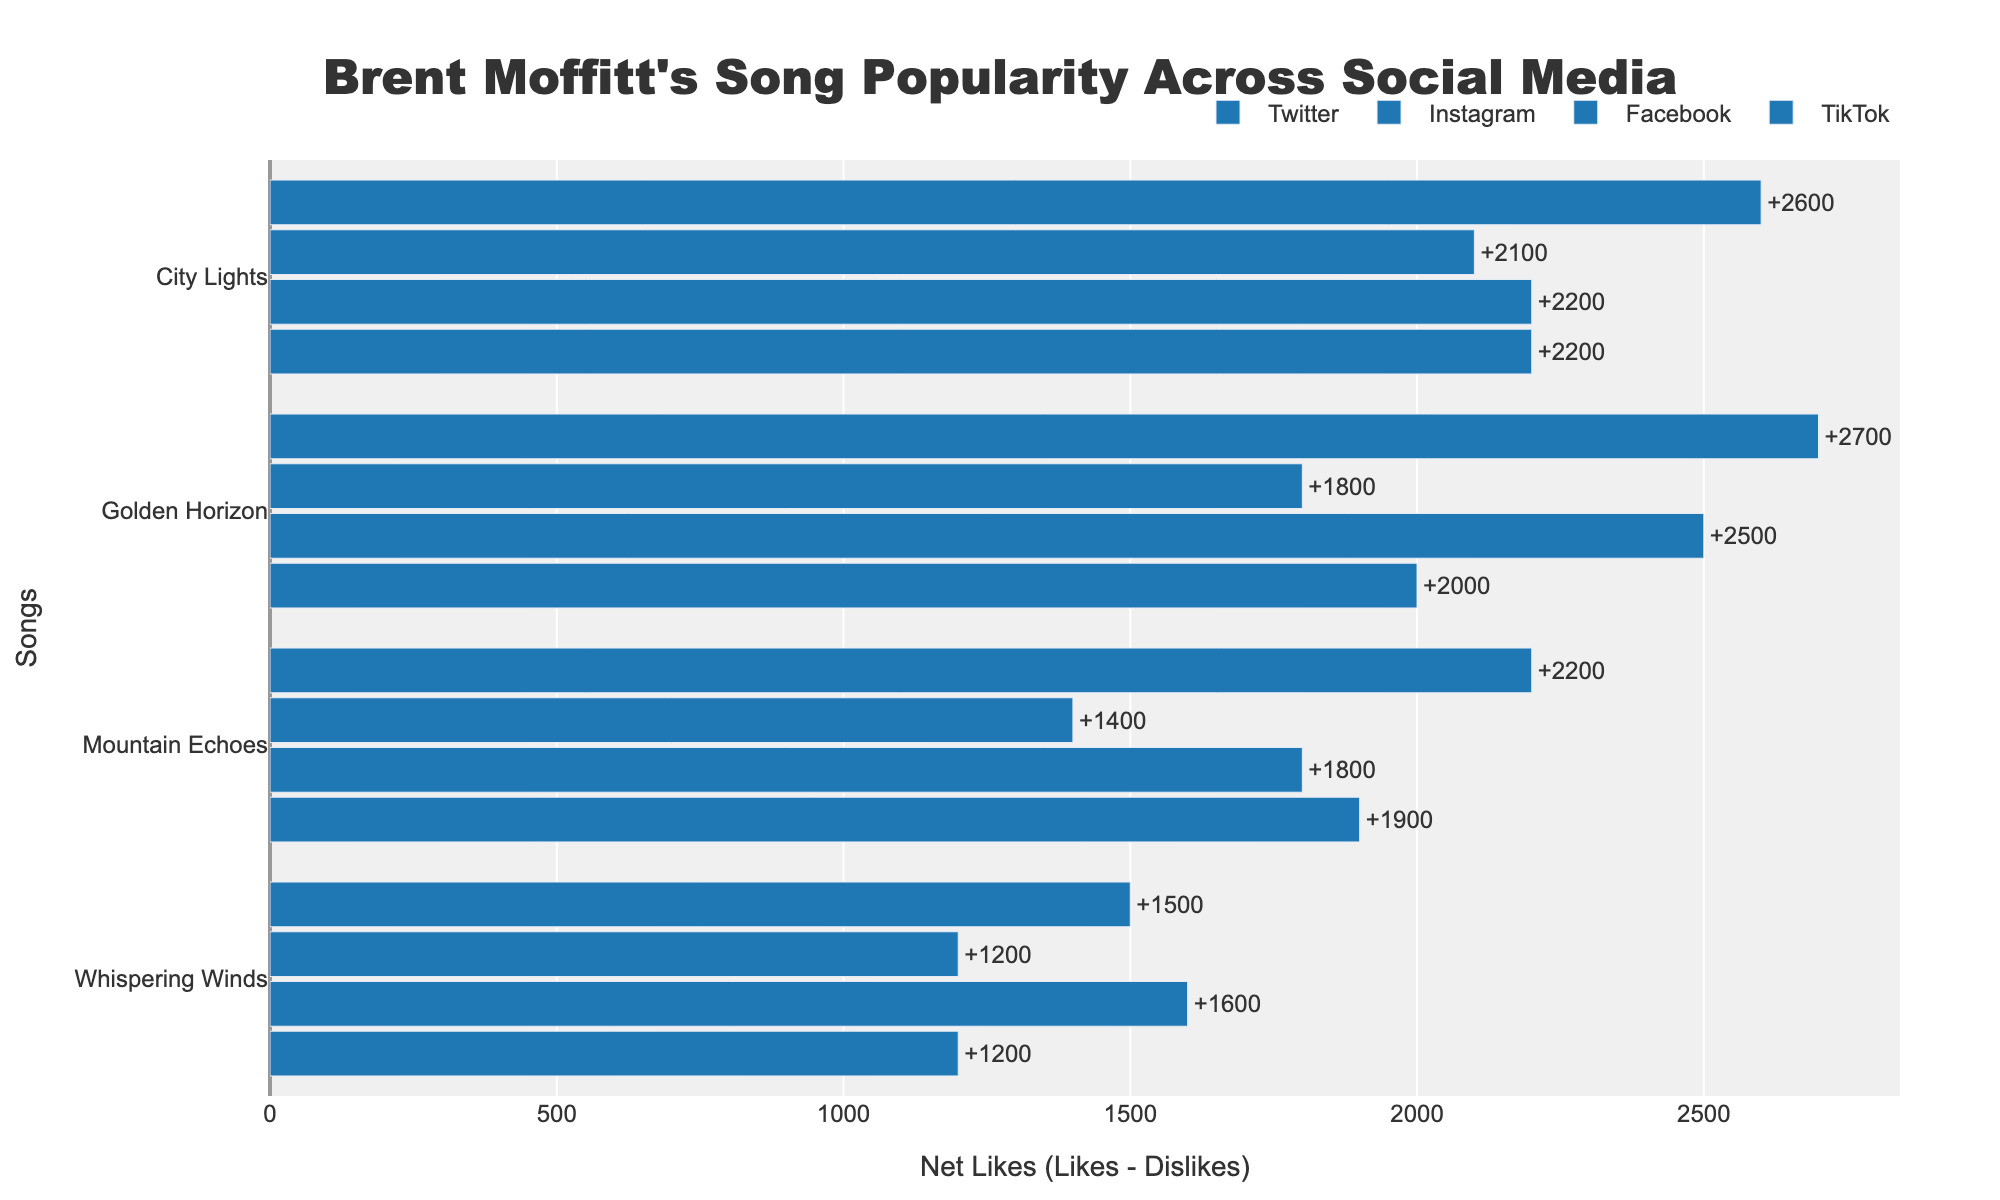How many net likes does "Golden Horizon" have on Twitter and Instagram combined? On Twitter, "Golden Horizon" has 2000 net likes (2500 Likes - 500 Dislikes). On Instagram, it has 2500 net likes (3200 Likes - 700 Dislikes). Summing them up, 2000 + 2500, the result is 4500 net likes.
Answer: 4500 Which song received the most net likes on TikTok? To determine this, we compare the net likes for each song on TikTok. "Golden Horizon" has 2700 net likes (3300 Likes - 600 Dislikes), "Whispering Winds" has 1500 net likes (2000 Likes - 500 Dislikes), "Mountain Echoes" has 2200 net likes (2700 Likes - 500 Dislikes), and "City Lights" has 2600 net likes (3500 Likes - 900 Dislikes). "Golden Horizon" has the most with 2700 net likes.
Answer: Golden Horizon How do the net likes for "City Lights" compare across all platforms? We need to compare the net likes for "City Lights" on each platform. Twitter: 2200 net likes (2800 Likes - 600 Dislikes), Instagram: 2200 net likes (3000 Likes - 800 Dislikes), Facebook: 2100 net likes (2600 Likes - 500 Dislikes), TikTok: 2600 net likes (3500 Likes - 900 Dislikes). TikTok has the highest net likes, followed by Twitter and Instagram (equal), and Facebook the lowest.
Answer: TikTok > Twitter = Instagram > Facebook Which platform generally has the highest net likes for Brent Moffitt's songs? To answer this, we observe the net likes sum for each platform. Summing the songs for each platform: Twitter - 1700 + 1200 + 1900 + 2200 = 7000, Instagram - 2500 + 1600 + 1800 + 2200 = 8100, Facebook - 1800 + 1200 + 1400 + 2100 = 6500, TikTok - 2700 + 1500 + 2200 + 2600 = 9000. TikTok has the highest total net likes.
Answer: TikTok For which song is the difference in net likes between Instagram and Facebook the largest? Determine the net likes differences for each song between Instagram and Facebook: "Golden Horizon" (2500 - 1800) = 700, "Whispering Winds" (1600 - 1200) = 400, "Mountain Echoes" (1800 - 1400) = 400, "City Lights" (2200 - 2100) = 100. The largest difference is for "Golden Horizon" with a difference of 700.
Answer: Golden Horizon What are the net likes for "Whispering Winds" across all platforms, and what's the total? Net likes for "Whispering Winds": Twitter - 1200 (1600 Likes - 400 Dislikes), Instagram - 1600 (1900 Likes - 300 Dislikes), Facebook - 1200 (1400 Likes - 200 Dislikes), TikTok - 1500 (2000 Likes - 500 Dislikes). Summing these, 1200 + 1600 + 1200 + 1500 = 5500.
Answer: 5500 Which song has the shortest bar on Facebook, and what does it indicate? The shortest bar represents the song with the fewest net likes on Facebook. "Whispering Winds" has 1200 net likes, "Mountain Echoes" has 1400, "Golden Horizon" has 1800, and "City Lights" has 2100. "Whispering Winds" has the shortest bar, indicating it has the least net likes on Facebook.
Answer: Whispering Winds Among all songs, which received the highest net likes on a single platform? Find the maximum net likes for each song on all platforms. "Golden Horizon" on TikTok has 2700, "Whispering Winds" on Instagram has 1600, "Mountain Echoes" on TikTok has 2200, and "City Lights" on TikTok has 2600. "Golden Horizon" on TikTok has the highest with 2700 net likes.
Answer: Golden Horizon on TikTok By how much do the net likes of "Mountain Echoes" on Twitter differ from those on Instagram? "Mountain Echoes" has net likes of 1900 on Twitter (2200 Likes - 300 Dislikes) and 1800 on Instagram (2400 Likes - 600 Dislikes). The difference between these is 1900 - 1800 = 100 net likes.
Answer: 100 